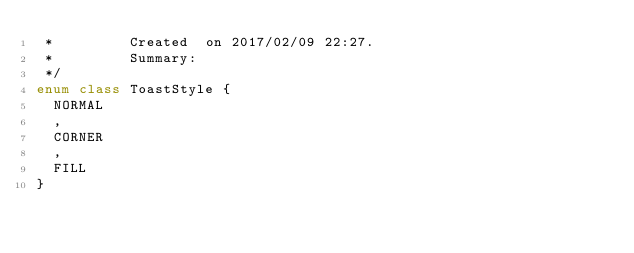Convert code to text. <code><loc_0><loc_0><loc_500><loc_500><_Kotlin_> *         Created  on 2017/02/09 22:27.
 *         Summary:
 */
enum class ToastStyle {
  NORMAL
  ,
  CORNER
  ,
  FILL
}</code> 